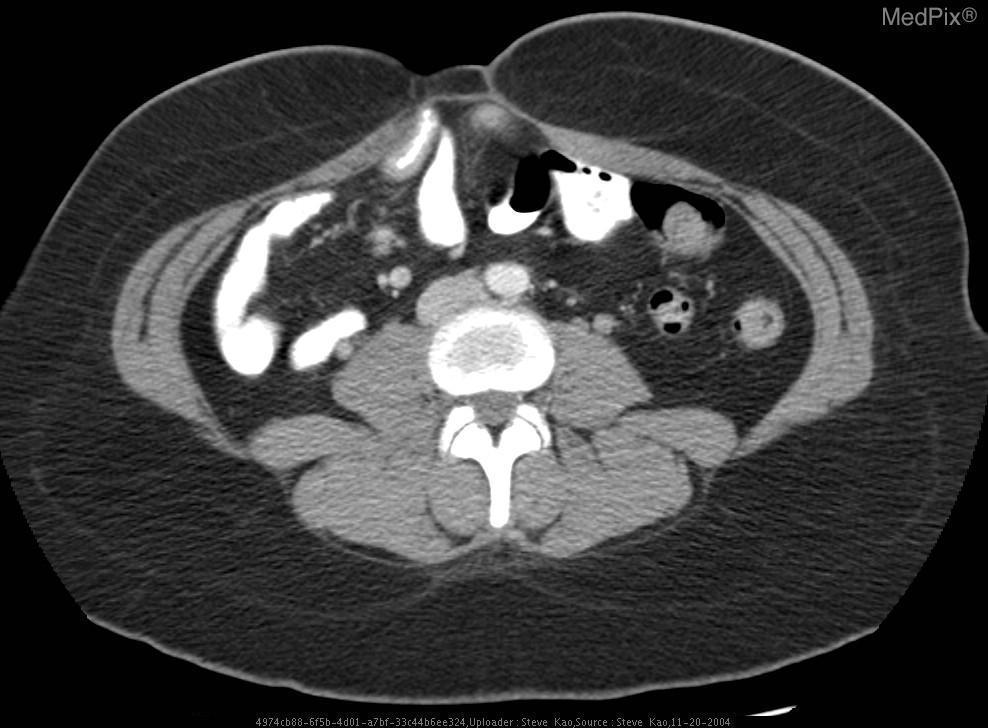What plane is the image in?
Be succinct. Axial. How can you tell that one side is small bowen and the other side is large bowel?
Be succinct. Location of the contrast?. How do you know that small bowel and colon are on different sides of midline?
Write a very short answer. Haustra. What are defining radiological features of large bowel?
Give a very brief answer. Air?. How do you distinguish large bowel?
Give a very brief answer. Haustra. What are defining radiological features of the small bowel?
Give a very brief answer. Not sure. How do you identify small bowel?
Short answer required. Plicae circulares. How can you tell contrast has been give orally?
Answer briefly. Bowel contents light up on image. Is the saggital plane?
Concise answer only. No. What could cause this finding?
Quick response, please. Congenital developmental disorder? history of surgery and past manipulation?. 